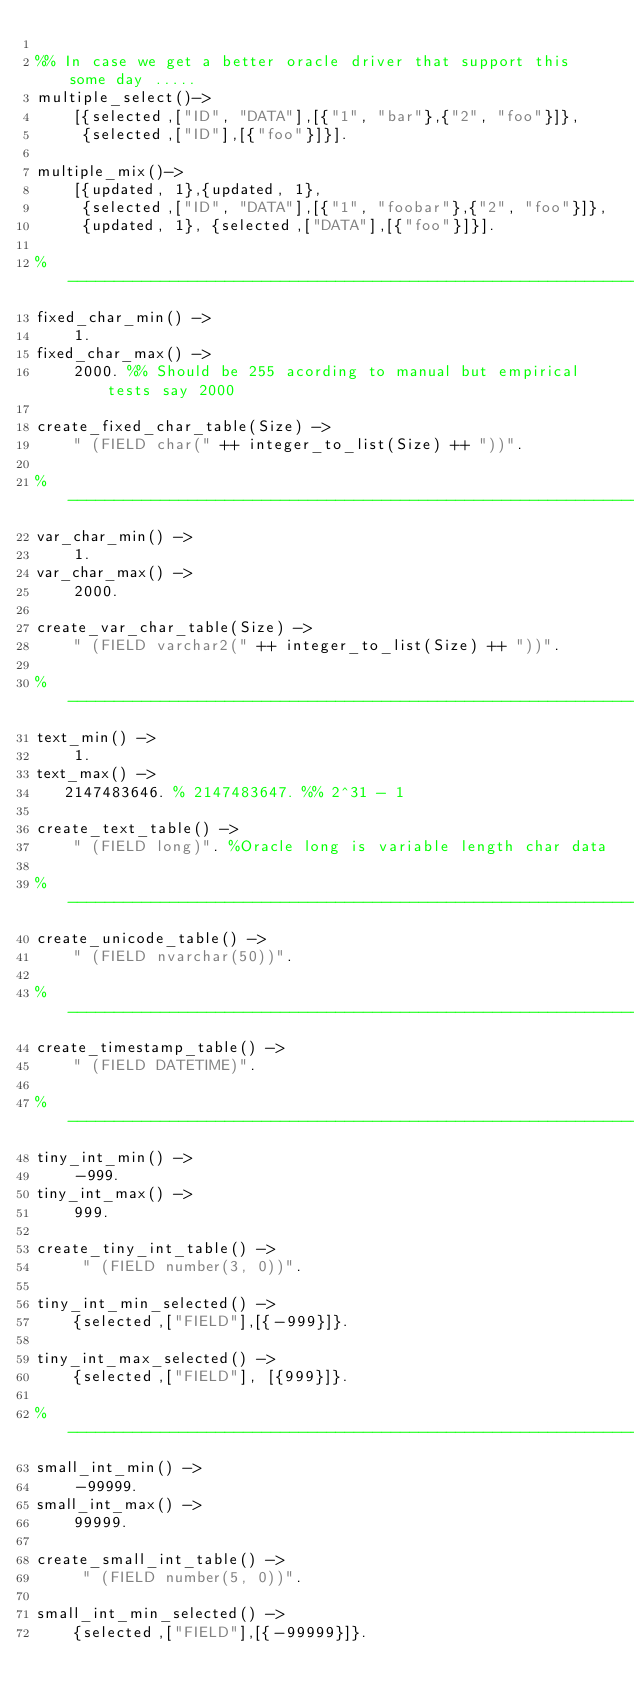Convert code to text. <code><loc_0><loc_0><loc_500><loc_500><_Erlang_>
%% In case we get a better oracle driver that support this some day .....
multiple_select()->
    [{selected,["ID", "DATA"],[{"1", "bar"},{"2", "foo"}]},
     {selected,["ID"],[{"foo"}]}].

multiple_mix()->
    [{updated, 1},{updated, 1},
     {selected,["ID", "DATA"],[{"1", "foobar"},{"2", "foo"}]},
     {updated, 1}, {selected,["DATA"],[{"foo"}]}].

%-------------------------------------------------------------------------
fixed_char_min() ->
    1.
fixed_char_max() ->
    2000. %% Should be 255 acording to manual but empirical tests say 2000

create_fixed_char_table(Size) ->
    " (FIELD char(" ++ integer_to_list(Size) ++ "))".

%-------------------------------------------------------------------------
var_char_min() ->
    1.
var_char_max() ->
    2000. 

create_var_char_table(Size) ->
    " (FIELD varchar2(" ++ integer_to_list(Size) ++ "))".

%-------------------------------------------------------------------------
text_min() ->
    1.
text_max() ->
   2147483646. % 2147483647. %% 2^31 - 1 

create_text_table() ->
    " (FIELD long)". %Oracle long is variable length char data

%-------------------------------------------------------------------------
create_unicode_table() ->
    " (FIELD nvarchar(50))".

%-------------------------------------------------------------------------
create_timestamp_table() ->
    " (FIELD DATETIME)". 

%-------------------------------------------------------------------------
tiny_int_min() ->
    -999.
tiny_int_max() ->
    999.

create_tiny_int_table() ->
     " (FIELD number(3, 0))".

tiny_int_min_selected() ->
    {selected,["FIELD"],[{-999}]}.

tiny_int_max_selected() ->
    {selected,["FIELD"], [{999}]}.

%-------------------------------------------------------------------------
small_int_min() ->
    -99999.
small_int_max() ->
    99999.

create_small_int_table() ->
     " (FIELD number(5, 0))".

small_int_min_selected() ->
    {selected,["FIELD"],[{-99999}]}.
</code> 